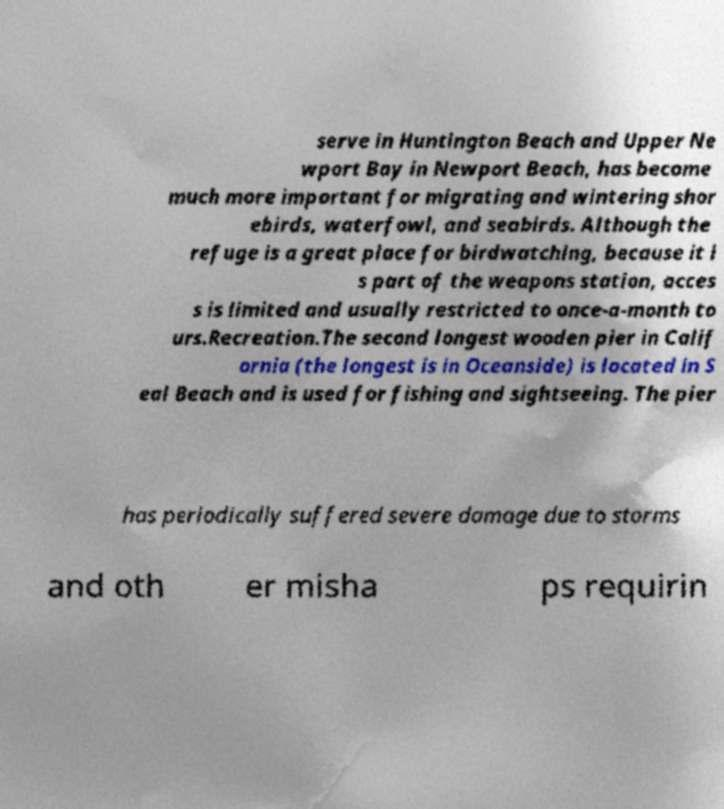There's text embedded in this image that I need extracted. Can you transcribe it verbatim? serve in Huntington Beach and Upper Ne wport Bay in Newport Beach, has become much more important for migrating and wintering shor ebirds, waterfowl, and seabirds. Although the refuge is a great place for birdwatching, because it i s part of the weapons station, acces s is limited and usually restricted to once-a-month to urs.Recreation.The second longest wooden pier in Calif ornia (the longest is in Oceanside) is located in S eal Beach and is used for fishing and sightseeing. The pier has periodically suffered severe damage due to storms and oth er misha ps requirin 